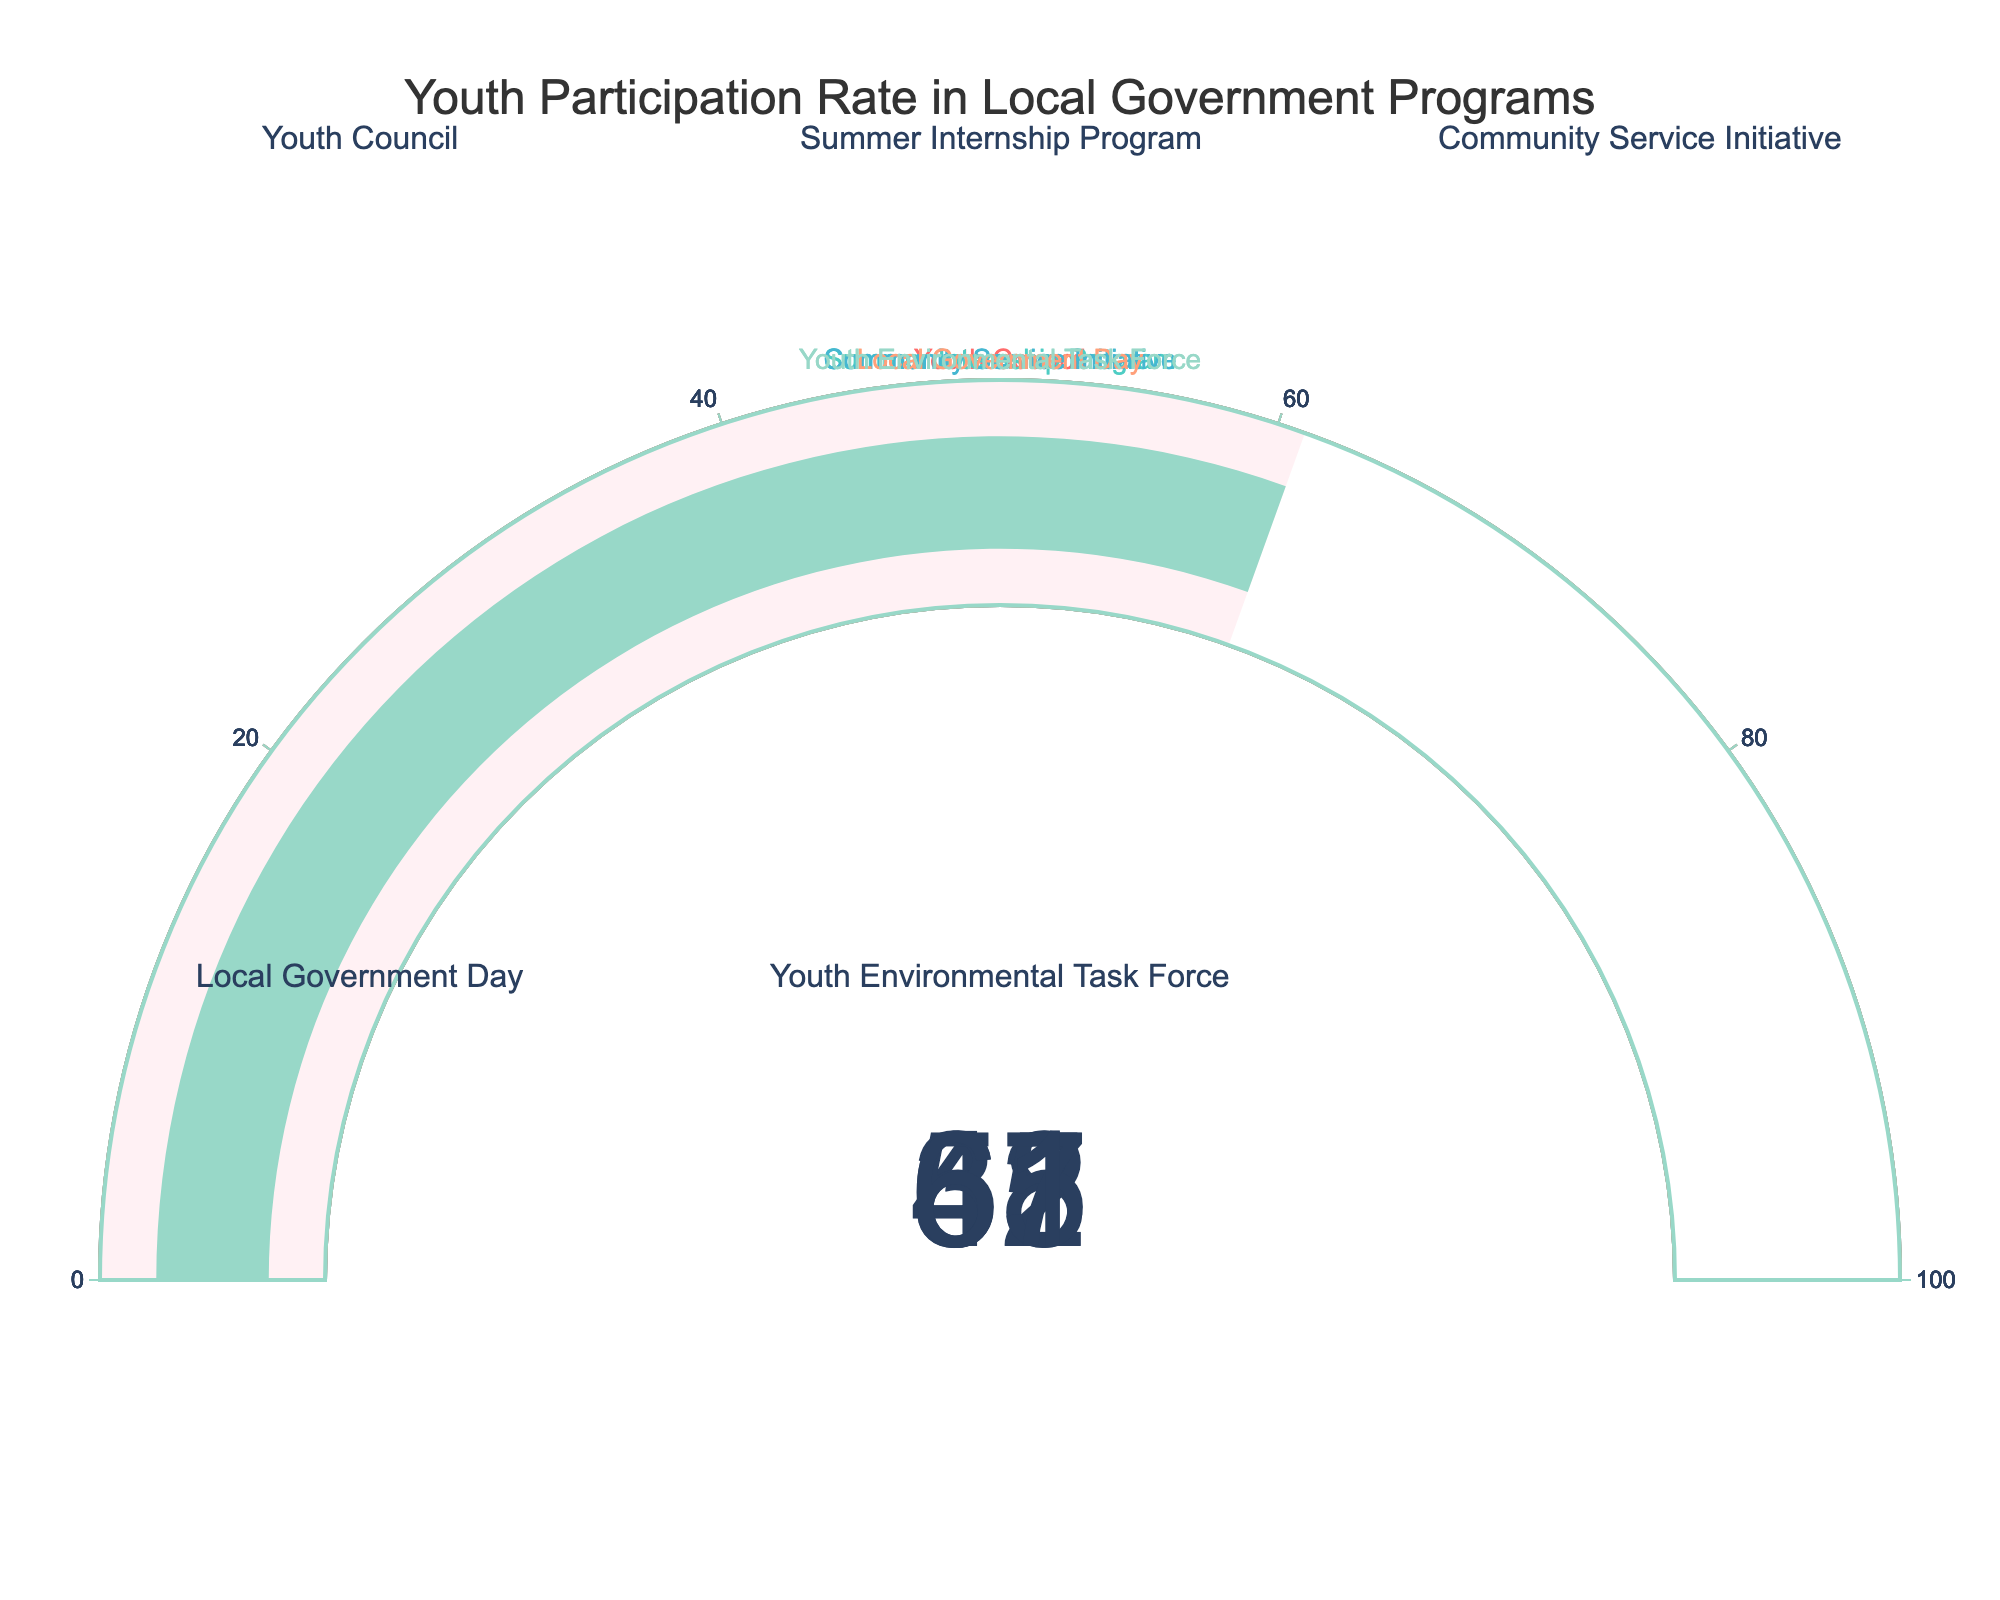What is the participation rate for the Youth Council program? The figure shows a gauge chart for each program's participation rate, and the Youth Council gauge displays 68%
Answer: 68% How many programs have a participation rate above 50%? Looking at the gauge charts, Youth Council (68%), Community Service Initiative (55%), and Youth Environmental Task Force (61%) have participation rates above 50%.
Answer: 3 Which program has the lowest participation rate? By observing the gauge charts, the Local Government Day has the lowest participation rate with 37%.
Answer: Local Government Day What is the average participation rate across all programs? Sum the participation rates (68 + 42 + 55 + 37 + 61) = 263, then divide by the number of programs, 263/5 = 52.6
Answer: 52.6% Is the participation rate of the Summer Internship Program higher or lower than the Community Service Initiative? The Summer Internship Program has a participation rate of 42%, while the Community Service Initiative has a rate of 55%. 42% is lower than 55%
Answer: Lower What's the difference in participation rate between the highest and lowest programs? The highest rate is 68% (Youth Council) and the lowest is 37% (Local Government Day). The difference is 68 - 37 = 31
Answer: 31% If a target participation rate is set at 50%, how many programs meet or exceed this target? By examining the gauge charts, Youth Council (68%), Community Service Initiative (55%), and Youth Environmental Task Force (61%) meet or exceed 50%
Answer: 3 Which two programs have their participation rates closest to each other? The participation rates for Community Service Initiative (55%) and Youth Environmental Task Force (61%) are closest, with a difference of 6%.
Answer: Community Service Initiative and Youth Environmental Task Force What is the combined participation rate of the Youth Environmental Task Force and Local Government Day? Adding the participation rates of Youth Environmental Task Force (61%) and Local Government Day (37%), we get 61 + 37 = 98
Answer: 98% 